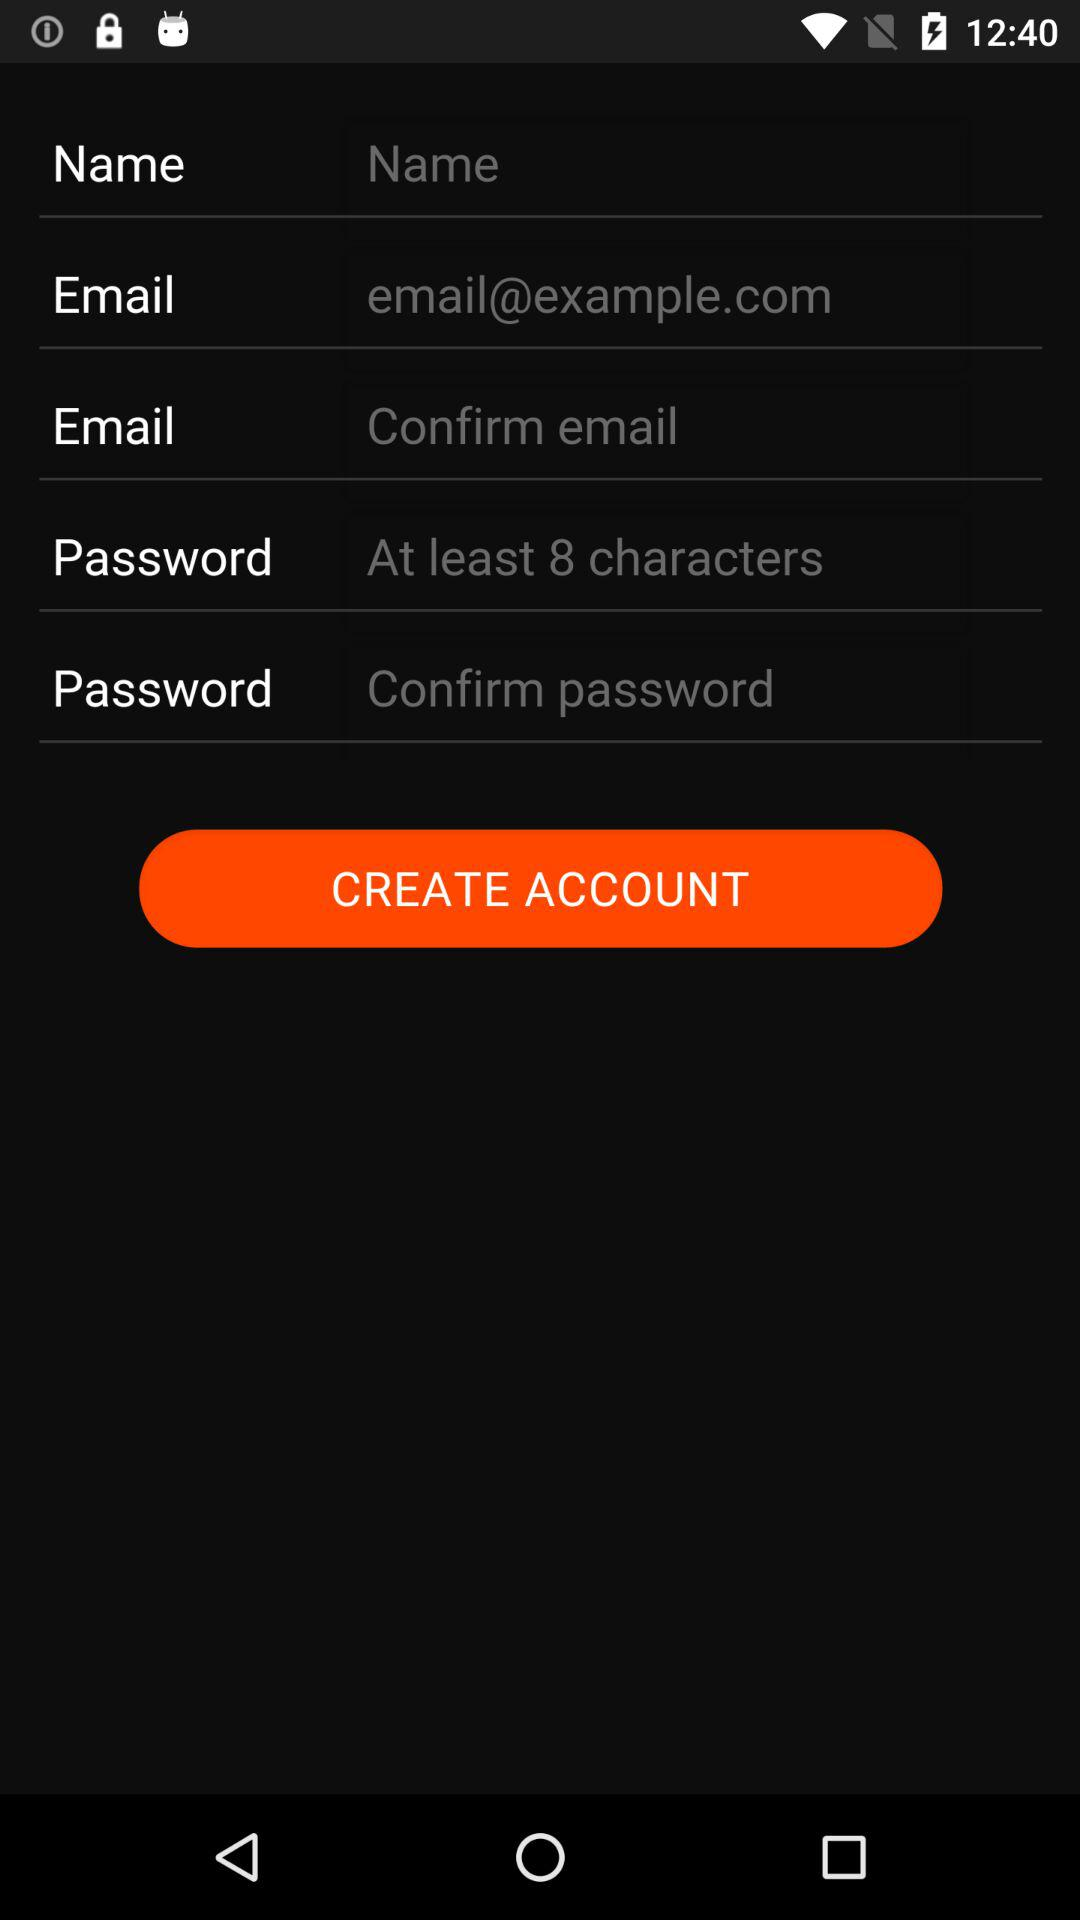What is the minimum number of characters required for a password? The minimum number of characters required for a password is 8. 